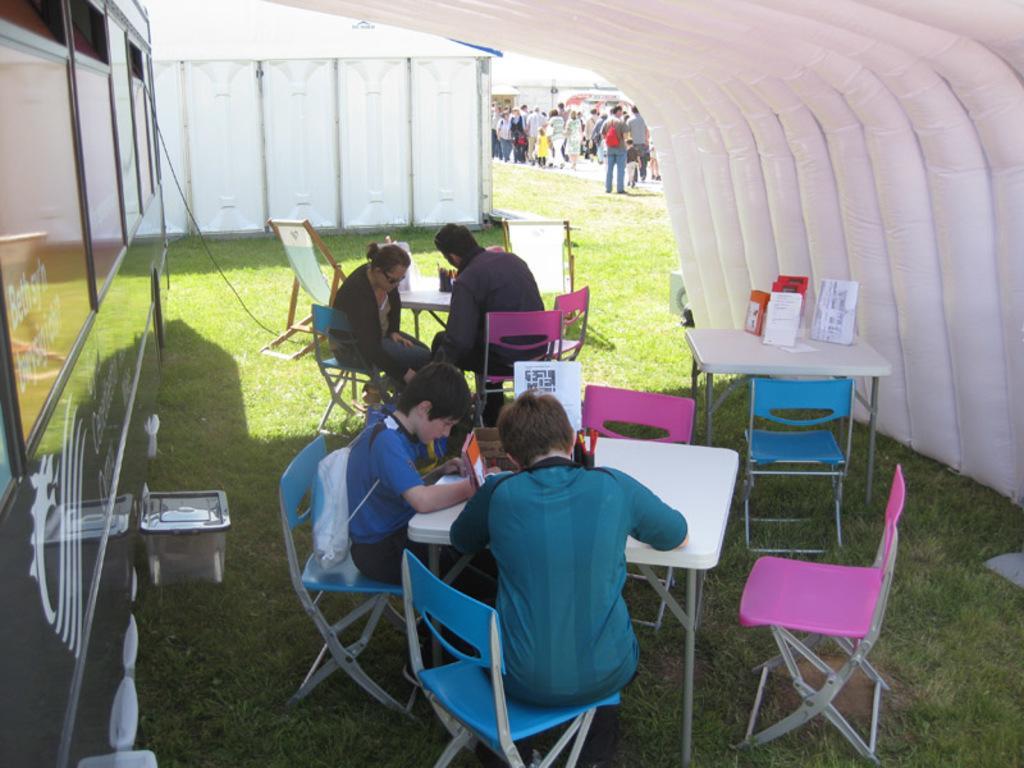Could you give a brief overview of what you see in this image? This is the picture of some people sitting on the chairs around the tables on which there are some things and behind them there are some other people standing. 